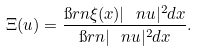<formula> <loc_0><loc_0><loc_500><loc_500>\Xi ( u ) = \frac { \i r n \xi ( x ) | \ n u | ^ { 2 } d x } { \i r n | \ n u | ^ { 2 } d x } .</formula> 